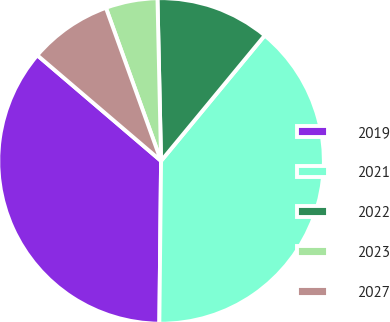<chart> <loc_0><loc_0><loc_500><loc_500><pie_chart><fcel>2019<fcel>2021<fcel>2022<fcel>2023<fcel>2027<nl><fcel>36.08%<fcel>39.18%<fcel>11.34%<fcel>5.15%<fcel>8.25%<nl></chart> 